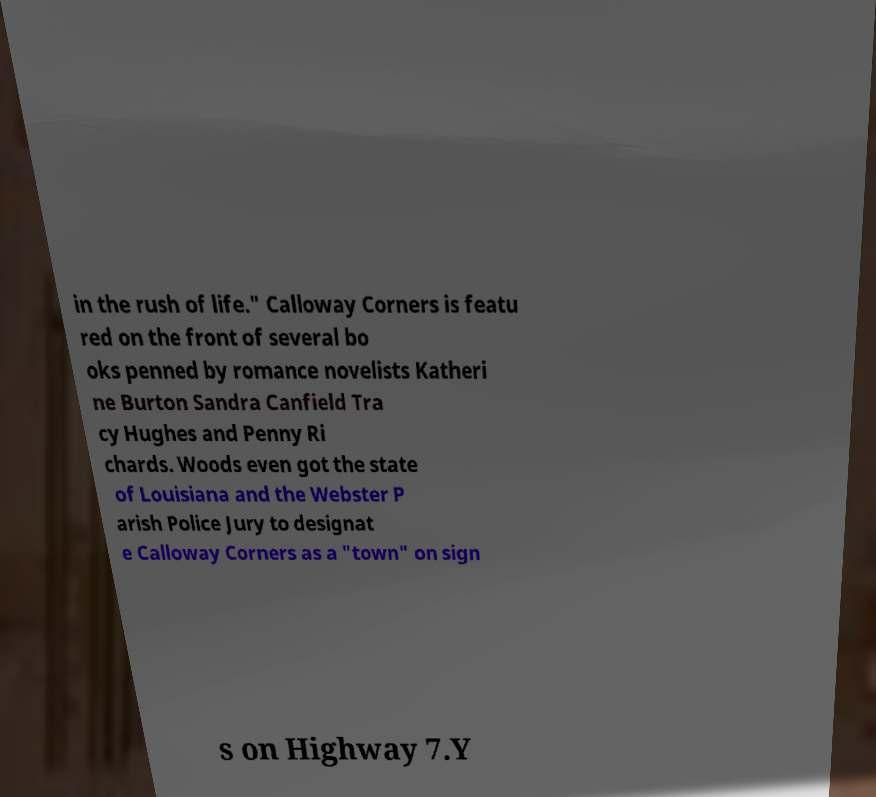Please read and relay the text visible in this image. What does it say? in the rush of life." Calloway Corners is featu red on the front of several bo oks penned by romance novelists Katheri ne Burton Sandra Canfield Tra cy Hughes and Penny Ri chards. Woods even got the state of Louisiana and the Webster P arish Police Jury to designat e Calloway Corners as a "town" on sign s on Highway 7.Y 